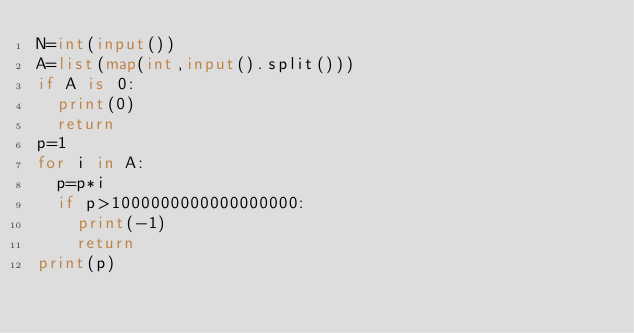<code> <loc_0><loc_0><loc_500><loc_500><_Python_>N=int(input())
A=list(map(int,input().split()))
if A is 0:
  print(0)
  return
p=1
for i in A:
  p=p*i
  if p>1000000000000000000:
    print(-1)
    return
print(p)  
  
  </code> 